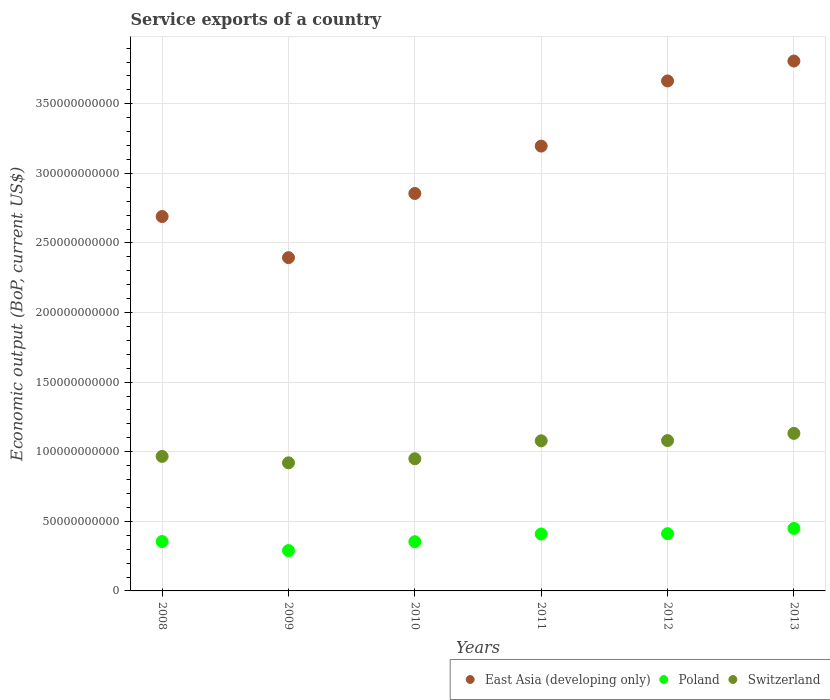How many different coloured dotlines are there?
Make the answer very short. 3. Is the number of dotlines equal to the number of legend labels?
Offer a terse response. Yes. What is the service exports in Poland in 2012?
Keep it short and to the point. 4.11e+1. Across all years, what is the maximum service exports in Poland?
Offer a terse response. 4.49e+1. Across all years, what is the minimum service exports in Switzerland?
Offer a very short reply. 9.20e+1. In which year was the service exports in Poland maximum?
Make the answer very short. 2013. What is the total service exports in Poland in the graph?
Provide a succinct answer. 2.27e+11. What is the difference between the service exports in Poland in 2008 and that in 2010?
Give a very brief answer. 1.49e+08. What is the difference between the service exports in East Asia (developing only) in 2012 and the service exports in Poland in 2008?
Your answer should be very brief. 3.31e+11. What is the average service exports in Switzerland per year?
Ensure brevity in your answer.  1.02e+11. In the year 2009, what is the difference between the service exports in Switzerland and service exports in Poland?
Give a very brief answer. 6.30e+1. What is the ratio of the service exports in Switzerland in 2010 to that in 2011?
Make the answer very short. 0.88. Is the difference between the service exports in Switzerland in 2008 and 2012 greater than the difference between the service exports in Poland in 2008 and 2012?
Offer a very short reply. No. What is the difference between the highest and the second highest service exports in Switzerland?
Provide a short and direct response. 5.18e+09. What is the difference between the highest and the lowest service exports in Switzerland?
Keep it short and to the point. 2.12e+1. Is the sum of the service exports in Switzerland in 2009 and 2010 greater than the maximum service exports in East Asia (developing only) across all years?
Provide a succinct answer. No. Is it the case that in every year, the sum of the service exports in Poland and service exports in Switzerland  is greater than the service exports in East Asia (developing only)?
Provide a succinct answer. No. Does the service exports in Switzerland monotonically increase over the years?
Offer a very short reply. No. How many dotlines are there?
Your answer should be compact. 3. How many years are there in the graph?
Ensure brevity in your answer.  6. What is the difference between two consecutive major ticks on the Y-axis?
Offer a terse response. 5.00e+1. Does the graph contain any zero values?
Ensure brevity in your answer.  No. Does the graph contain grids?
Offer a very short reply. Yes. Where does the legend appear in the graph?
Your answer should be very brief. Bottom right. How many legend labels are there?
Your answer should be very brief. 3. How are the legend labels stacked?
Offer a very short reply. Horizontal. What is the title of the graph?
Offer a terse response. Service exports of a country. What is the label or title of the X-axis?
Make the answer very short. Years. What is the label or title of the Y-axis?
Offer a very short reply. Economic output (BoP, current US$). What is the Economic output (BoP, current US$) in East Asia (developing only) in 2008?
Provide a short and direct response. 2.69e+11. What is the Economic output (BoP, current US$) of Poland in 2008?
Provide a short and direct response. 3.55e+1. What is the Economic output (BoP, current US$) in Switzerland in 2008?
Offer a very short reply. 9.66e+1. What is the Economic output (BoP, current US$) of East Asia (developing only) in 2009?
Your answer should be compact. 2.39e+11. What is the Economic output (BoP, current US$) in Poland in 2009?
Offer a very short reply. 2.90e+1. What is the Economic output (BoP, current US$) in Switzerland in 2009?
Ensure brevity in your answer.  9.20e+1. What is the Economic output (BoP, current US$) in East Asia (developing only) in 2010?
Provide a short and direct response. 2.86e+11. What is the Economic output (BoP, current US$) in Poland in 2010?
Your answer should be very brief. 3.54e+1. What is the Economic output (BoP, current US$) in Switzerland in 2010?
Provide a succinct answer. 9.50e+1. What is the Economic output (BoP, current US$) of East Asia (developing only) in 2011?
Your answer should be compact. 3.20e+11. What is the Economic output (BoP, current US$) in Poland in 2011?
Your response must be concise. 4.09e+1. What is the Economic output (BoP, current US$) in Switzerland in 2011?
Ensure brevity in your answer.  1.08e+11. What is the Economic output (BoP, current US$) in East Asia (developing only) in 2012?
Offer a terse response. 3.66e+11. What is the Economic output (BoP, current US$) of Poland in 2012?
Offer a very short reply. 4.11e+1. What is the Economic output (BoP, current US$) in Switzerland in 2012?
Your answer should be very brief. 1.08e+11. What is the Economic output (BoP, current US$) in East Asia (developing only) in 2013?
Offer a terse response. 3.81e+11. What is the Economic output (BoP, current US$) in Poland in 2013?
Ensure brevity in your answer.  4.49e+1. What is the Economic output (BoP, current US$) of Switzerland in 2013?
Give a very brief answer. 1.13e+11. Across all years, what is the maximum Economic output (BoP, current US$) of East Asia (developing only)?
Keep it short and to the point. 3.81e+11. Across all years, what is the maximum Economic output (BoP, current US$) in Poland?
Give a very brief answer. 4.49e+1. Across all years, what is the maximum Economic output (BoP, current US$) of Switzerland?
Keep it short and to the point. 1.13e+11. Across all years, what is the minimum Economic output (BoP, current US$) of East Asia (developing only)?
Provide a short and direct response. 2.39e+11. Across all years, what is the minimum Economic output (BoP, current US$) of Poland?
Provide a short and direct response. 2.90e+1. Across all years, what is the minimum Economic output (BoP, current US$) in Switzerland?
Keep it short and to the point. 9.20e+1. What is the total Economic output (BoP, current US$) in East Asia (developing only) in the graph?
Provide a succinct answer. 1.86e+12. What is the total Economic output (BoP, current US$) of Poland in the graph?
Give a very brief answer. 2.27e+11. What is the total Economic output (BoP, current US$) in Switzerland in the graph?
Ensure brevity in your answer.  6.13e+11. What is the difference between the Economic output (BoP, current US$) of East Asia (developing only) in 2008 and that in 2009?
Provide a short and direct response. 2.96e+1. What is the difference between the Economic output (BoP, current US$) of Poland in 2008 and that in 2009?
Offer a very short reply. 6.51e+09. What is the difference between the Economic output (BoP, current US$) of Switzerland in 2008 and that in 2009?
Offer a terse response. 4.61e+09. What is the difference between the Economic output (BoP, current US$) in East Asia (developing only) in 2008 and that in 2010?
Ensure brevity in your answer.  -1.66e+1. What is the difference between the Economic output (BoP, current US$) in Poland in 2008 and that in 2010?
Your answer should be compact. 1.49e+08. What is the difference between the Economic output (BoP, current US$) in Switzerland in 2008 and that in 2010?
Give a very brief answer. 1.68e+09. What is the difference between the Economic output (BoP, current US$) of East Asia (developing only) in 2008 and that in 2011?
Keep it short and to the point. -5.06e+1. What is the difference between the Economic output (BoP, current US$) of Poland in 2008 and that in 2011?
Offer a terse response. -5.38e+09. What is the difference between the Economic output (BoP, current US$) in Switzerland in 2008 and that in 2011?
Give a very brief answer. -1.12e+1. What is the difference between the Economic output (BoP, current US$) in East Asia (developing only) in 2008 and that in 2012?
Your answer should be compact. -9.74e+1. What is the difference between the Economic output (BoP, current US$) in Poland in 2008 and that in 2012?
Provide a succinct answer. -5.61e+09. What is the difference between the Economic output (BoP, current US$) in Switzerland in 2008 and that in 2012?
Your response must be concise. -1.14e+1. What is the difference between the Economic output (BoP, current US$) in East Asia (developing only) in 2008 and that in 2013?
Your response must be concise. -1.12e+11. What is the difference between the Economic output (BoP, current US$) of Poland in 2008 and that in 2013?
Offer a terse response. -9.40e+09. What is the difference between the Economic output (BoP, current US$) of Switzerland in 2008 and that in 2013?
Keep it short and to the point. -1.65e+1. What is the difference between the Economic output (BoP, current US$) in East Asia (developing only) in 2009 and that in 2010?
Offer a very short reply. -4.61e+1. What is the difference between the Economic output (BoP, current US$) of Poland in 2009 and that in 2010?
Provide a short and direct response. -6.36e+09. What is the difference between the Economic output (BoP, current US$) of Switzerland in 2009 and that in 2010?
Your answer should be very brief. -2.93e+09. What is the difference between the Economic output (BoP, current US$) of East Asia (developing only) in 2009 and that in 2011?
Provide a short and direct response. -8.02e+1. What is the difference between the Economic output (BoP, current US$) in Poland in 2009 and that in 2011?
Your answer should be compact. -1.19e+1. What is the difference between the Economic output (BoP, current US$) of Switzerland in 2009 and that in 2011?
Offer a terse response. -1.58e+1. What is the difference between the Economic output (BoP, current US$) in East Asia (developing only) in 2009 and that in 2012?
Offer a terse response. -1.27e+11. What is the difference between the Economic output (BoP, current US$) in Poland in 2009 and that in 2012?
Give a very brief answer. -1.21e+1. What is the difference between the Economic output (BoP, current US$) of Switzerland in 2009 and that in 2012?
Your answer should be compact. -1.60e+1. What is the difference between the Economic output (BoP, current US$) of East Asia (developing only) in 2009 and that in 2013?
Give a very brief answer. -1.41e+11. What is the difference between the Economic output (BoP, current US$) in Poland in 2009 and that in 2013?
Give a very brief answer. -1.59e+1. What is the difference between the Economic output (BoP, current US$) in Switzerland in 2009 and that in 2013?
Keep it short and to the point. -2.12e+1. What is the difference between the Economic output (BoP, current US$) of East Asia (developing only) in 2010 and that in 2011?
Your response must be concise. -3.40e+1. What is the difference between the Economic output (BoP, current US$) of Poland in 2010 and that in 2011?
Provide a succinct answer. -5.52e+09. What is the difference between the Economic output (BoP, current US$) in Switzerland in 2010 and that in 2011?
Offer a terse response. -1.29e+1. What is the difference between the Economic output (BoP, current US$) in East Asia (developing only) in 2010 and that in 2012?
Your answer should be compact. -8.08e+1. What is the difference between the Economic output (BoP, current US$) of Poland in 2010 and that in 2012?
Your response must be concise. -5.76e+09. What is the difference between the Economic output (BoP, current US$) in Switzerland in 2010 and that in 2012?
Your answer should be very brief. -1.30e+1. What is the difference between the Economic output (BoP, current US$) of East Asia (developing only) in 2010 and that in 2013?
Offer a terse response. -9.51e+1. What is the difference between the Economic output (BoP, current US$) in Poland in 2010 and that in 2013?
Provide a short and direct response. -9.55e+09. What is the difference between the Economic output (BoP, current US$) in Switzerland in 2010 and that in 2013?
Offer a very short reply. -1.82e+1. What is the difference between the Economic output (BoP, current US$) in East Asia (developing only) in 2011 and that in 2012?
Offer a very short reply. -4.68e+1. What is the difference between the Economic output (BoP, current US$) of Poland in 2011 and that in 2012?
Ensure brevity in your answer.  -2.36e+08. What is the difference between the Economic output (BoP, current US$) of Switzerland in 2011 and that in 2012?
Your response must be concise. -1.53e+08. What is the difference between the Economic output (BoP, current US$) of East Asia (developing only) in 2011 and that in 2013?
Offer a very short reply. -6.11e+1. What is the difference between the Economic output (BoP, current US$) of Poland in 2011 and that in 2013?
Your response must be concise. -4.02e+09. What is the difference between the Economic output (BoP, current US$) of Switzerland in 2011 and that in 2013?
Your answer should be compact. -5.34e+09. What is the difference between the Economic output (BoP, current US$) in East Asia (developing only) in 2012 and that in 2013?
Provide a short and direct response. -1.43e+1. What is the difference between the Economic output (BoP, current US$) of Poland in 2012 and that in 2013?
Your answer should be very brief. -3.79e+09. What is the difference between the Economic output (BoP, current US$) of Switzerland in 2012 and that in 2013?
Keep it short and to the point. -5.18e+09. What is the difference between the Economic output (BoP, current US$) in East Asia (developing only) in 2008 and the Economic output (BoP, current US$) in Poland in 2009?
Keep it short and to the point. 2.40e+11. What is the difference between the Economic output (BoP, current US$) in East Asia (developing only) in 2008 and the Economic output (BoP, current US$) in Switzerland in 2009?
Offer a very short reply. 1.77e+11. What is the difference between the Economic output (BoP, current US$) of Poland in 2008 and the Economic output (BoP, current US$) of Switzerland in 2009?
Give a very brief answer. -5.65e+1. What is the difference between the Economic output (BoP, current US$) of East Asia (developing only) in 2008 and the Economic output (BoP, current US$) of Poland in 2010?
Your answer should be very brief. 2.34e+11. What is the difference between the Economic output (BoP, current US$) of East Asia (developing only) in 2008 and the Economic output (BoP, current US$) of Switzerland in 2010?
Make the answer very short. 1.74e+11. What is the difference between the Economic output (BoP, current US$) of Poland in 2008 and the Economic output (BoP, current US$) of Switzerland in 2010?
Your answer should be very brief. -5.95e+1. What is the difference between the Economic output (BoP, current US$) of East Asia (developing only) in 2008 and the Economic output (BoP, current US$) of Poland in 2011?
Ensure brevity in your answer.  2.28e+11. What is the difference between the Economic output (BoP, current US$) of East Asia (developing only) in 2008 and the Economic output (BoP, current US$) of Switzerland in 2011?
Ensure brevity in your answer.  1.61e+11. What is the difference between the Economic output (BoP, current US$) in Poland in 2008 and the Economic output (BoP, current US$) in Switzerland in 2011?
Ensure brevity in your answer.  -7.23e+1. What is the difference between the Economic output (BoP, current US$) in East Asia (developing only) in 2008 and the Economic output (BoP, current US$) in Poland in 2012?
Your answer should be compact. 2.28e+11. What is the difference between the Economic output (BoP, current US$) of East Asia (developing only) in 2008 and the Economic output (BoP, current US$) of Switzerland in 2012?
Your response must be concise. 1.61e+11. What is the difference between the Economic output (BoP, current US$) in Poland in 2008 and the Economic output (BoP, current US$) in Switzerland in 2012?
Keep it short and to the point. -7.25e+1. What is the difference between the Economic output (BoP, current US$) of East Asia (developing only) in 2008 and the Economic output (BoP, current US$) of Poland in 2013?
Keep it short and to the point. 2.24e+11. What is the difference between the Economic output (BoP, current US$) in East Asia (developing only) in 2008 and the Economic output (BoP, current US$) in Switzerland in 2013?
Provide a short and direct response. 1.56e+11. What is the difference between the Economic output (BoP, current US$) of Poland in 2008 and the Economic output (BoP, current US$) of Switzerland in 2013?
Keep it short and to the point. -7.77e+1. What is the difference between the Economic output (BoP, current US$) of East Asia (developing only) in 2009 and the Economic output (BoP, current US$) of Poland in 2010?
Provide a succinct answer. 2.04e+11. What is the difference between the Economic output (BoP, current US$) in East Asia (developing only) in 2009 and the Economic output (BoP, current US$) in Switzerland in 2010?
Ensure brevity in your answer.  1.44e+11. What is the difference between the Economic output (BoP, current US$) in Poland in 2009 and the Economic output (BoP, current US$) in Switzerland in 2010?
Your answer should be compact. -6.60e+1. What is the difference between the Economic output (BoP, current US$) of East Asia (developing only) in 2009 and the Economic output (BoP, current US$) of Poland in 2011?
Keep it short and to the point. 1.99e+11. What is the difference between the Economic output (BoP, current US$) of East Asia (developing only) in 2009 and the Economic output (BoP, current US$) of Switzerland in 2011?
Your response must be concise. 1.32e+11. What is the difference between the Economic output (BoP, current US$) of Poland in 2009 and the Economic output (BoP, current US$) of Switzerland in 2011?
Provide a short and direct response. -7.89e+1. What is the difference between the Economic output (BoP, current US$) of East Asia (developing only) in 2009 and the Economic output (BoP, current US$) of Poland in 2012?
Make the answer very short. 1.98e+11. What is the difference between the Economic output (BoP, current US$) in East Asia (developing only) in 2009 and the Economic output (BoP, current US$) in Switzerland in 2012?
Keep it short and to the point. 1.31e+11. What is the difference between the Economic output (BoP, current US$) in Poland in 2009 and the Economic output (BoP, current US$) in Switzerland in 2012?
Provide a succinct answer. -7.90e+1. What is the difference between the Economic output (BoP, current US$) in East Asia (developing only) in 2009 and the Economic output (BoP, current US$) in Poland in 2013?
Keep it short and to the point. 1.95e+11. What is the difference between the Economic output (BoP, current US$) of East Asia (developing only) in 2009 and the Economic output (BoP, current US$) of Switzerland in 2013?
Your response must be concise. 1.26e+11. What is the difference between the Economic output (BoP, current US$) in Poland in 2009 and the Economic output (BoP, current US$) in Switzerland in 2013?
Provide a short and direct response. -8.42e+1. What is the difference between the Economic output (BoP, current US$) of East Asia (developing only) in 2010 and the Economic output (BoP, current US$) of Poland in 2011?
Provide a succinct answer. 2.45e+11. What is the difference between the Economic output (BoP, current US$) of East Asia (developing only) in 2010 and the Economic output (BoP, current US$) of Switzerland in 2011?
Ensure brevity in your answer.  1.78e+11. What is the difference between the Economic output (BoP, current US$) of Poland in 2010 and the Economic output (BoP, current US$) of Switzerland in 2011?
Offer a very short reply. -7.25e+1. What is the difference between the Economic output (BoP, current US$) in East Asia (developing only) in 2010 and the Economic output (BoP, current US$) in Poland in 2012?
Your response must be concise. 2.44e+11. What is the difference between the Economic output (BoP, current US$) of East Asia (developing only) in 2010 and the Economic output (BoP, current US$) of Switzerland in 2012?
Ensure brevity in your answer.  1.78e+11. What is the difference between the Economic output (BoP, current US$) in Poland in 2010 and the Economic output (BoP, current US$) in Switzerland in 2012?
Keep it short and to the point. -7.27e+1. What is the difference between the Economic output (BoP, current US$) in East Asia (developing only) in 2010 and the Economic output (BoP, current US$) in Poland in 2013?
Give a very brief answer. 2.41e+11. What is the difference between the Economic output (BoP, current US$) in East Asia (developing only) in 2010 and the Economic output (BoP, current US$) in Switzerland in 2013?
Make the answer very short. 1.72e+11. What is the difference between the Economic output (BoP, current US$) of Poland in 2010 and the Economic output (BoP, current US$) of Switzerland in 2013?
Offer a terse response. -7.78e+1. What is the difference between the Economic output (BoP, current US$) in East Asia (developing only) in 2011 and the Economic output (BoP, current US$) in Poland in 2012?
Offer a very short reply. 2.78e+11. What is the difference between the Economic output (BoP, current US$) in East Asia (developing only) in 2011 and the Economic output (BoP, current US$) in Switzerland in 2012?
Ensure brevity in your answer.  2.12e+11. What is the difference between the Economic output (BoP, current US$) in Poland in 2011 and the Economic output (BoP, current US$) in Switzerland in 2012?
Your answer should be compact. -6.71e+1. What is the difference between the Economic output (BoP, current US$) of East Asia (developing only) in 2011 and the Economic output (BoP, current US$) of Poland in 2013?
Your answer should be compact. 2.75e+11. What is the difference between the Economic output (BoP, current US$) in East Asia (developing only) in 2011 and the Economic output (BoP, current US$) in Switzerland in 2013?
Your response must be concise. 2.06e+11. What is the difference between the Economic output (BoP, current US$) in Poland in 2011 and the Economic output (BoP, current US$) in Switzerland in 2013?
Your response must be concise. -7.23e+1. What is the difference between the Economic output (BoP, current US$) in East Asia (developing only) in 2012 and the Economic output (BoP, current US$) in Poland in 2013?
Provide a succinct answer. 3.21e+11. What is the difference between the Economic output (BoP, current US$) in East Asia (developing only) in 2012 and the Economic output (BoP, current US$) in Switzerland in 2013?
Offer a very short reply. 2.53e+11. What is the difference between the Economic output (BoP, current US$) of Poland in 2012 and the Economic output (BoP, current US$) of Switzerland in 2013?
Give a very brief answer. -7.21e+1. What is the average Economic output (BoP, current US$) of East Asia (developing only) per year?
Ensure brevity in your answer.  3.10e+11. What is the average Economic output (BoP, current US$) in Poland per year?
Give a very brief answer. 3.78e+1. What is the average Economic output (BoP, current US$) in Switzerland per year?
Offer a very short reply. 1.02e+11. In the year 2008, what is the difference between the Economic output (BoP, current US$) in East Asia (developing only) and Economic output (BoP, current US$) in Poland?
Offer a very short reply. 2.33e+11. In the year 2008, what is the difference between the Economic output (BoP, current US$) in East Asia (developing only) and Economic output (BoP, current US$) in Switzerland?
Your response must be concise. 1.72e+11. In the year 2008, what is the difference between the Economic output (BoP, current US$) in Poland and Economic output (BoP, current US$) in Switzerland?
Your response must be concise. -6.11e+1. In the year 2009, what is the difference between the Economic output (BoP, current US$) of East Asia (developing only) and Economic output (BoP, current US$) of Poland?
Your answer should be very brief. 2.10e+11. In the year 2009, what is the difference between the Economic output (BoP, current US$) in East Asia (developing only) and Economic output (BoP, current US$) in Switzerland?
Make the answer very short. 1.47e+11. In the year 2009, what is the difference between the Economic output (BoP, current US$) in Poland and Economic output (BoP, current US$) in Switzerland?
Your answer should be compact. -6.30e+1. In the year 2010, what is the difference between the Economic output (BoP, current US$) in East Asia (developing only) and Economic output (BoP, current US$) in Poland?
Give a very brief answer. 2.50e+11. In the year 2010, what is the difference between the Economic output (BoP, current US$) of East Asia (developing only) and Economic output (BoP, current US$) of Switzerland?
Your response must be concise. 1.91e+11. In the year 2010, what is the difference between the Economic output (BoP, current US$) in Poland and Economic output (BoP, current US$) in Switzerland?
Keep it short and to the point. -5.96e+1. In the year 2011, what is the difference between the Economic output (BoP, current US$) in East Asia (developing only) and Economic output (BoP, current US$) in Poland?
Your answer should be very brief. 2.79e+11. In the year 2011, what is the difference between the Economic output (BoP, current US$) of East Asia (developing only) and Economic output (BoP, current US$) of Switzerland?
Keep it short and to the point. 2.12e+11. In the year 2011, what is the difference between the Economic output (BoP, current US$) of Poland and Economic output (BoP, current US$) of Switzerland?
Offer a terse response. -6.70e+1. In the year 2012, what is the difference between the Economic output (BoP, current US$) in East Asia (developing only) and Economic output (BoP, current US$) in Poland?
Give a very brief answer. 3.25e+11. In the year 2012, what is the difference between the Economic output (BoP, current US$) in East Asia (developing only) and Economic output (BoP, current US$) in Switzerland?
Make the answer very short. 2.58e+11. In the year 2012, what is the difference between the Economic output (BoP, current US$) of Poland and Economic output (BoP, current US$) of Switzerland?
Make the answer very short. -6.69e+1. In the year 2013, what is the difference between the Economic output (BoP, current US$) of East Asia (developing only) and Economic output (BoP, current US$) of Poland?
Provide a succinct answer. 3.36e+11. In the year 2013, what is the difference between the Economic output (BoP, current US$) of East Asia (developing only) and Economic output (BoP, current US$) of Switzerland?
Give a very brief answer. 2.68e+11. In the year 2013, what is the difference between the Economic output (BoP, current US$) in Poland and Economic output (BoP, current US$) in Switzerland?
Your answer should be very brief. -6.83e+1. What is the ratio of the Economic output (BoP, current US$) in East Asia (developing only) in 2008 to that in 2009?
Your response must be concise. 1.12. What is the ratio of the Economic output (BoP, current US$) of Poland in 2008 to that in 2009?
Make the answer very short. 1.22. What is the ratio of the Economic output (BoP, current US$) in Switzerland in 2008 to that in 2009?
Offer a very short reply. 1.05. What is the ratio of the Economic output (BoP, current US$) of East Asia (developing only) in 2008 to that in 2010?
Provide a short and direct response. 0.94. What is the ratio of the Economic output (BoP, current US$) of Switzerland in 2008 to that in 2010?
Offer a terse response. 1.02. What is the ratio of the Economic output (BoP, current US$) of East Asia (developing only) in 2008 to that in 2011?
Give a very brief answer. 0.84. What is the ratio of the Economic output (BoP, current US$) in Poland in 2008 to that in 2011?
Your response must be concise. 0.87. What is the ratio of the Economic output (BoP, current US$) of Switzerland in 2008 to that in 2011?
Your answer should be very brief. 0.9. What is the ratio of the Economic output (BoP, current US$) of East Asia (developing only) in 2008 to that in 2012?
Your answer should be very brief. 0.73. What is the ratio of the Economic output (BoP, current US$) in Poland in 2008 to that in 2012?
Your answer should be compact. 0.86. What is the ratio of the Economic output (BoP, current US$) of Switzerland in 2008 to that in 2012?
Offer a terse response. 0.89. What is the ratio of the Economic output (BoP, current US$) of East Asia (developing only) in 2008 to that in 2013?
Ensure brevity in your answer.  0.71. What is the ratio of the Economic output (BoP, current US$) in Poland in 2008 to that in 2013?
Your answer should be compact. 0.79. What is the ratio of the Economic output (BoP, current US$) of Switzerland in 2008 to that in 2013?
Make the answer very short. 0.85. What is the ratio of the Economic output (BoP, current US$) in East Asia (developing only) in 2009 to that in 2010?
Your response must be concise. 0.84. What is the ratio of the Economic output (BoP, current US$) of Poland in 2009 to that in 2010?
Offer a very short reply. 0.82. What is the ratio of the Economic output (BoP, current US$) in Switzerland in 2009 to that in 2010?
Offer a terse response. 0.97. What is the ratio of the Economic output (BoP, current US$) in East Asia (developing only) in 2009 to that in 2011?
Make the answer very short. 0.75. What is the ratio of the Economic output (BoP, current US$) of Poland in 2009 to that in 2011?
Keep it short and to the point. 0.71. What is the ratio of the Economic output (BoP, current US$) of Switzerland in 2009 to that in 2011?
Offer a very short reply. 0.85. What is the ratio of the Economic output (BoP, current US$) in East Asia (developing only) in 2009 to that in 2012?
Ensure brevity in your answer.  0.65. What is the ratio of the Economic output (BoP, current US$) of Poland in 2009 to that in 2012?
Offer a very short reply. 0.71. What is the ratio of the Economic output (BoP, current US$) of Switzerland in 2009 to that in 2012?
Provide a short and direct response. 0.85. What is the ratio of the Economic output (BoP, current US$) of East Asia (developing only) in 2009 to that in 2013?
Your answer should be compact. 0.63. What is the ratio of the Economic output (BoP, current US$) in Poland in 2009 to that in 2013?
Your response must be concise. 0.65. What is the ratio of the Economic output (BoP, current US$) of Switzerland in 2009 to that in 2013?
Your answer should be compact. 0.81. What is the ratio of the Economic output (BoP, current US$) in East Asia (developing only) in 2010 to that in 2011?
Your response must be concise. 0.89. What is the ratio of the Economic output (BoP, current US$) in Poland in 2010 to that in 2011?
Your answer should be compact. 0.86. What is the ratio of the Economic output (BoP, current US$) in Switzerland in 2010 to that in 2011?
Give a very brief answer. 0.88. What is the ratio of the Economic output (BoP, current US$) in East Asia (developing only) in 2010 to that in 2012?
Your answer should be compact. 0.78. What is the ratio of the Economic output (BoP, current US$) of Poland in 2010 to that in 2012?
Your response must be concise. 0.86. What is the ratio of the Economic output (BoP, current US$) in Switzerland in 2010 to that in 2012?
Your response must be concise. 0.88. What is the ratio of the Economic output (BoP, current US$) in East Asia (developing only) in 2010 to that in 2013?
Make the answer very short. 0.75. What is the ratio of the Economic output (BoP, current US$) of Poland in 2010 to that in 2013?
Make the answer very short. 0.79. What is the ratio of the Economic output (BoP, current US$) in Switzerland in 2010 to that in 2013?
Make the answer very short. 0.84. What is the ratio of the Economic output (BoP, current US$) in East Asia (developing only) in 2011 to that in 2012?
Your answer should be compact. 0.87. What is the ratio of the Economic output (BoP, current US$) in Poland in 2011 to that in 2012?
Provide a short and direct response. 0.99. What is the ratio of the Economic output (BoP, current US$) in Switzerland in 2011 to that in 2012?
Offer a terse response. 1. What is the ratio of the Economic output (BoP, current US$) in East Asia (developing only) in 2011 to that in 2013?
Your answer should be very brief. 0.84. What is the ratio of the Economic output (BoP, current US$) of Poland in 2011 to that in 2013?
Make the answer very short. 0.91. What is the ratio of the Economic output (BoP, current US$) of Switzerland in 2011 to that in 2013?
Make the answer very short. 0.95. What is the ratio of the Economic output (BoP, current US$) of East Asia (developing only) in 2012 to that in 2013?
Provide a short and direct response. 0.96. What is the ratio of the Economic output (BoP, current US$) of Poland in 2012 to that in 2013?
Provide a succinct answer. 0.92. What is the ratio of the Economic output (BoP, current US$) in Switzerland in 2012 to that in 2013?
Your answer should be compact. 0.95. What is the difference between the highest and the second highest Economic output (BoP, current US$) of East Asia (developing only)?
Provide a short and direct response. 1.43e+1. What is the difference between the highest and the second highest Economic output (BoP, current US$) in Poland?
Keep it short and to the point. 3.79e+09. What is the difference between the highest and the second highest Economic output (BoP, current US$) in Switzerland?
Your answer should be compact. 5.18e+09. What is the difference between the highest and the lowest Economic output (BoP, current US$) of East Asia (developing only)?
Offer a very short reply. 1.41e+11. What is the difference between the highest and the lowest Economic output (BoP, current US$) in Poland?
Offer a very short reply. 1.59e+1. What is the difference between the highest and the lowest Economic output (BoP, current US$) of Switzerland?
Your answer should be compact. 2.12e+1. 